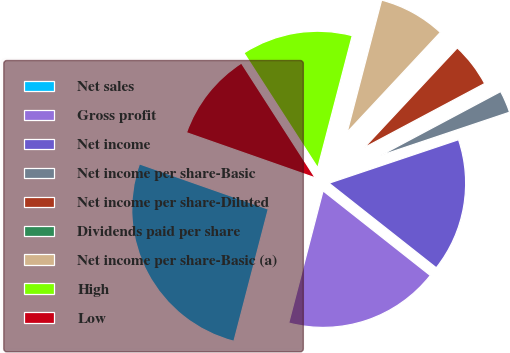Convert chart to OTSL. <chart><loc_0><loc_0><loc_500><loc_500><pie_chart><fcel>Net sales<fcel>Gross profit<fcel>Net income<fcel>Net income per share-Basic<fcel>Net income per share-Diluted<fcel>Dividends paid per share<fcel>Net income per share-Basic (a)<fcel>High<fcel>Low<nl><fcel>26.32%<fcel>18.42%<fcel>15.79%<fcel>2.63%<fcel>5.26%<fcel>0.0%<fcel>7.89%<fcel>13.16%<fcel>10.53%<nl></chart> 